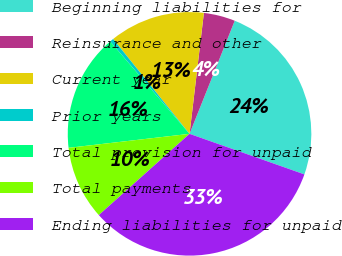Convert chart. <chart><loc_0><loc_0><loc_500><loc_500><pie_chart><fcel>Beginning liabilities for<fcel>Reinsurance and other<fcel>Current year<fcel>Prior years<fcel>Total provision for unpaid<fcel>Total payments<fcel>Ending liabilities for unpaid<nl><fcel>24.35%<fcel>4.17%<fcel>12.67%<fcel>0.5%<fcel>15.54%<fcel>9.79%<fcel>32.97%<nl></chart> 